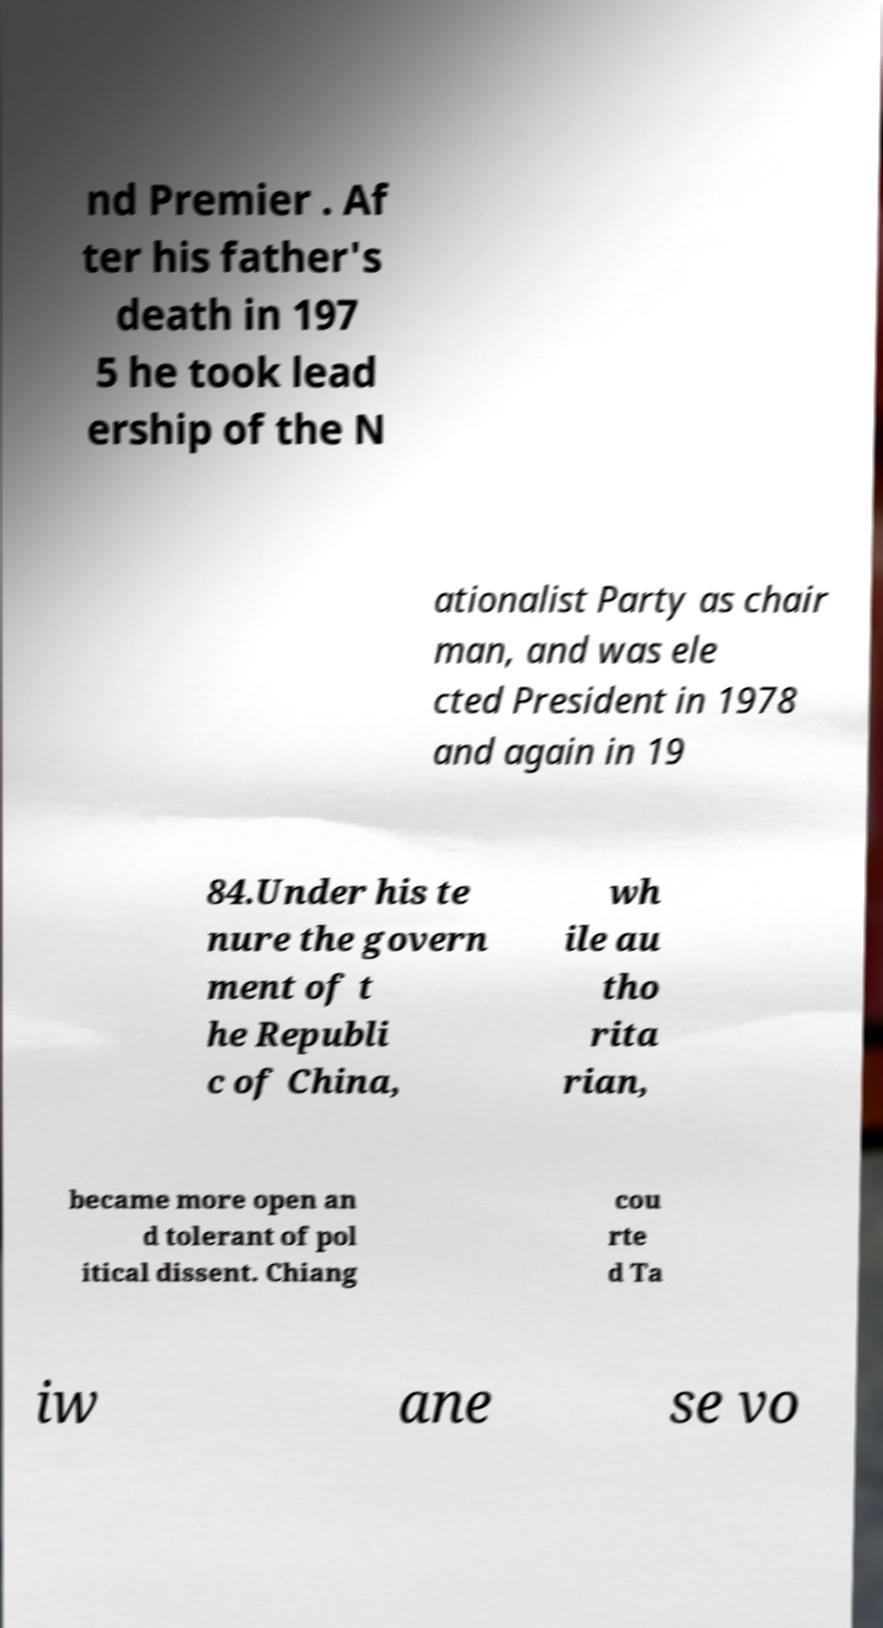Please identify and transcribe the text found in this image. nd Premier . Af ter his father's death in 197 5 he took lead ership of the N ationalist Party as chair man, and was ele cted President in 1978 and again in 19 84.Under his te nure the govern ment of t he Republi c of China, wh ile au tho rita rian, became more open an d tolerant of pol itical dissent. Chiang cou rte d Ta iw ane se vo 